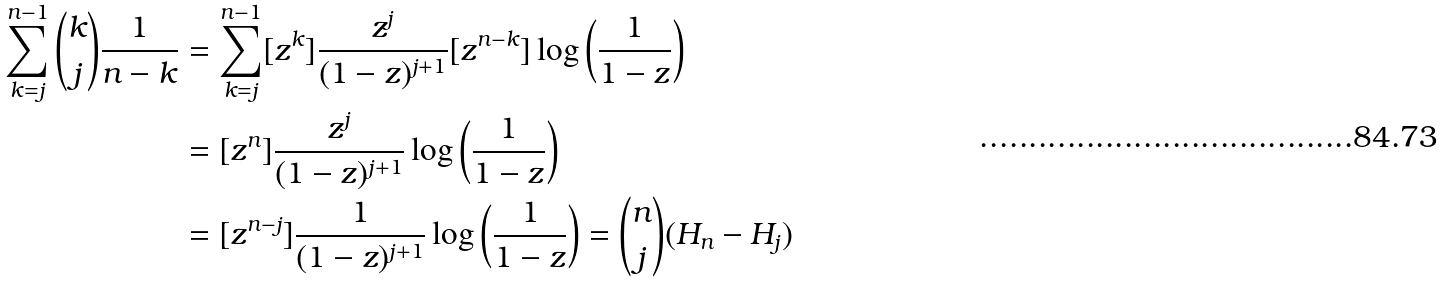<formula> <loc_0><loc_0><loc_500><loc_500>\sum _ { k = j } ^ { n - 1 } \binom { k } { j } \frac { 1 } { n - k } & = \sum _ { k = j } ^ { n - 1 } [ z ^ { k } ] \frac { z ^ { j } } { ( 1 - z ) ^ { j + 1 } } [ z ^ { n - k } ] \log \left ( \frac { 1 } { 1 - z } \right ) \\ & = [ z ^ { n } ] \frac { z ^ { j } } { ( 1 - z ) ^ { j + 1 } } \log \left ( \frac { 1 } { 1 - z } \right ) \\ & = [ z ^ { n - j } ] \frac { 1 } { ( 1 - z ) ^ { j + 1 } } \log \left ( \frac { 1 } { 1 - z } \right ) = \binom { n } { j } ( H _ { n } - H _ { j } )</formula> 